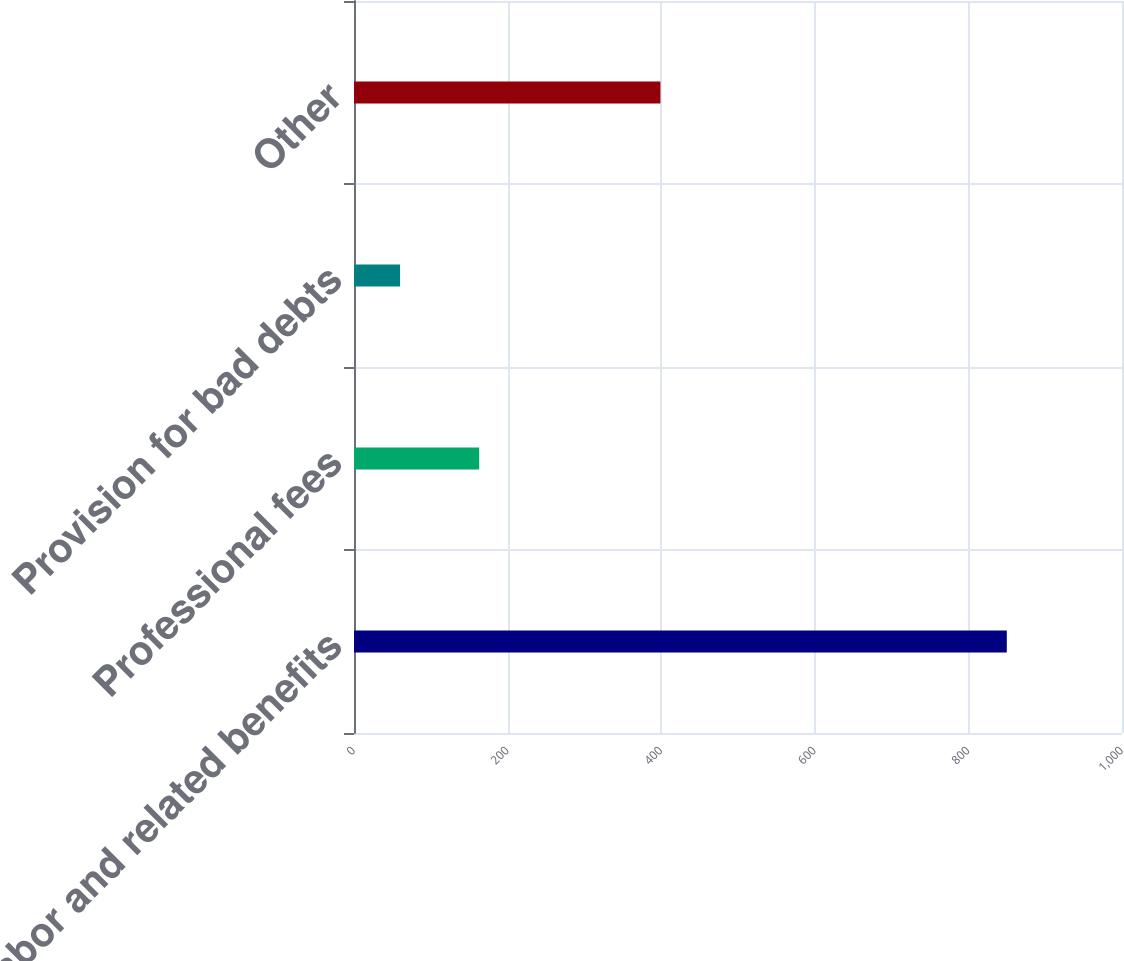Convert chart to OTSL. <chart><loc_0><loc_0><loc_500><loc_500><bar_chart><fcel>Labor and related benefits<fcel>Professional fees<fcel>Provision for bad debts<fcel>Other<nl><fcel>850<fcel>163<fcel>60<fcel>399<nl></chart> 